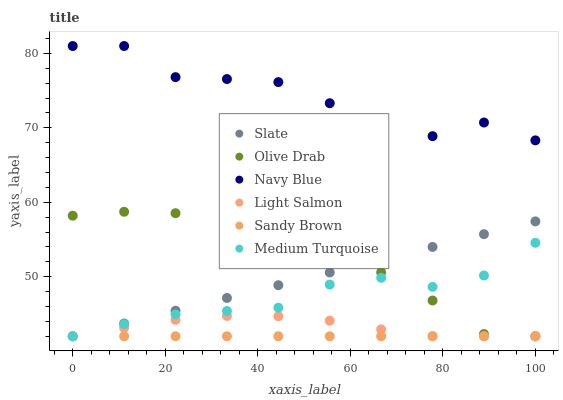Does Sandy Brown have the minimum area under the curve?
Answer yes or no. Yes. Does Navy Blue have the maximum area under the curve?
Answer yes or no. Yes. Does Slate have the minimum area under the curve?
Answer yes or no. No. Does Slate have the maximum area under the curve?
Answer yes or no. No. Is Sandy Brown the smoothest?
Answer yes or no. Yes. Is Navy Blue the roughest?
Answer yes or no. Yes. Is Slate the smoothest?
Answer yes or no. No. Is Slate the roughest?
Answer yes or no. No. Does Light Salmon have the lowest value?
Answer yes or no. Yes. Does Navy Blue have the lowest value?
Answer yes or no. No. Does Navy Blue have the highest value?
Answer yes or no. Yes. Does Slate have the highest value?
Answer yes or no. No. Is Medium Turquoise less than Navy Blue?
Answer yes or no. Yes. Is Navy Blue greater than Slate?
Answer yes or no. Yes. Does Slate intersect Medium Turquoise?
Answer yes or no. Yes. Is Slate less than Medium Turquoise?
Answer yes or no. No. Is Slate greater than Medium Turquoise?
Answer yes or no. No. Does Medium Turquoise intersect Navy Blue?
Answer yes or no. No. 